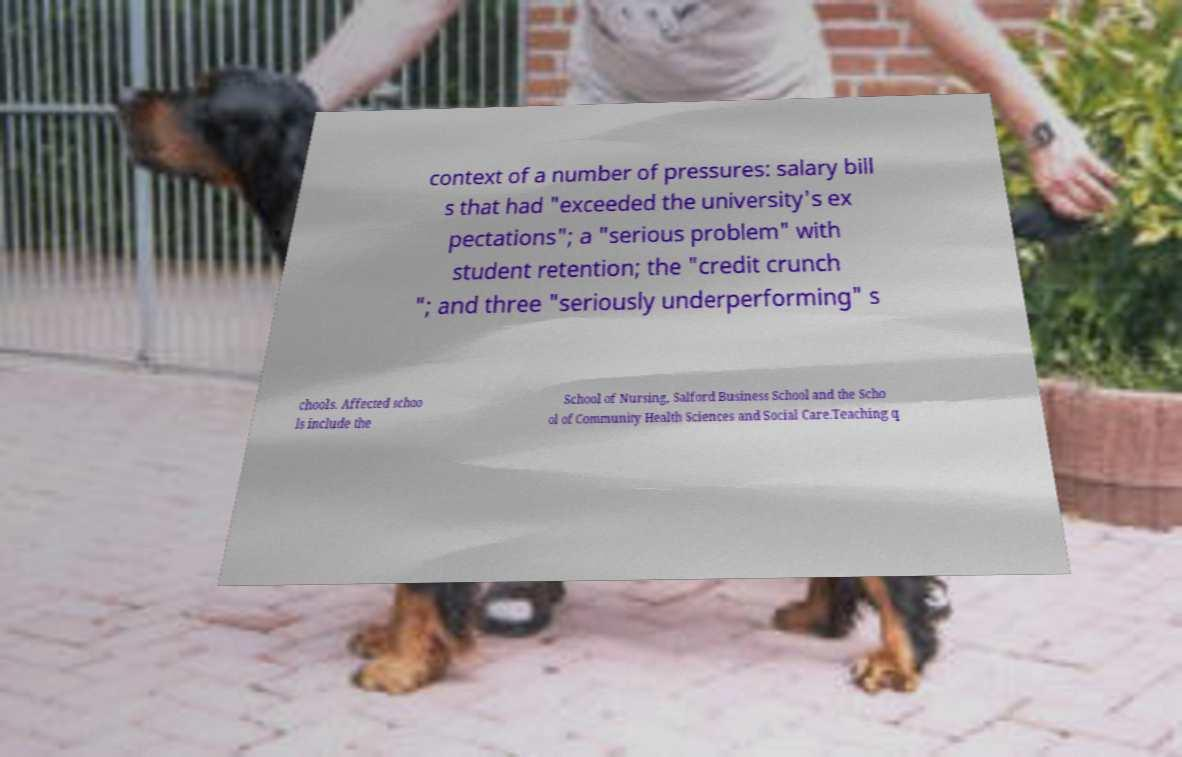Could you extract and type out the text from this image? context of a number of pressures: salary bill s that had "exceeded the university's ex pectations"; a "serious problem" with student retention; the "credit crunch "; and three "seriously underperforming" s chools. Affected schoo ls include the School of Nursing, Salford Business School and the Scho ol of Community Health Sciences and Social Care.Teaching q 